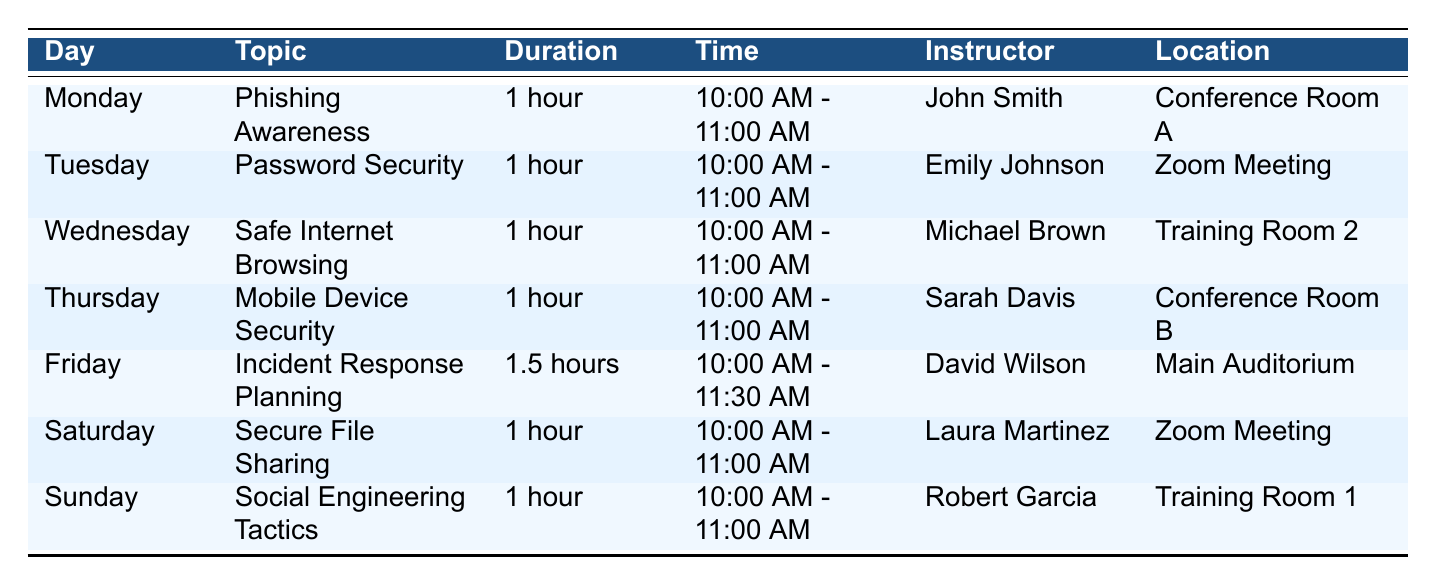What topic is covered on Monday? The table lists various topics for each day of the week. On Monday, the topic is specifically noted as "Phishing Awareness."
Answer: Phishing Awareness Who is the instructor for the session on Friday? By referencing the table, we see that Friday's session focuses on "Incident Response Planning," and the instructor listed is "David Wilson."
Answer: David Wilson Which day has a longer training duration? The table shows that Friday's session has a duration of "1.5 hours," while all other sessions last "1 hour." Therefore, Friday has the longest training duration.
Answer: Friday Does the "Password Security" session take place in a physical location? The table indicates that the "Password Security" session occurs in a "Zoom Meeting," which means it is not held in a physical location.
Answer: No What is the total duration of training sessions scheduled from Monday to Saturday? To find the total duration, we account for Monday to Saturday sessions: Monday (1) + Tuesday (1) + Wednesday (1) + Thursday (1) + Friday (1.5) + Saturday (1) = 6.5 hours total.
Answer: 6.5 hours On which day is "Social Engineering Tactics" taught, and where? The table specifies that "Social Engineering Tactics" is taught on Sunday in "Training Room 1."
Answer: Sunday, Training Room 1 Is there a session that takes place in "Conference Room A"? Checking the table reveals that the session covering "Phishing Awareness" on Monday is held in "Conference Room A." Thus, the answer is yes.
Answer: Yes How many different instructors lead the sessions during the week? By examining the table, we find the unique instructors listed are John Smith, Emily Johnson, Michael Brown, Sarah Davis, David Wilson, Laura Martinez, and Robert Garcia, totaling 7 instructors.
Answer: 7 